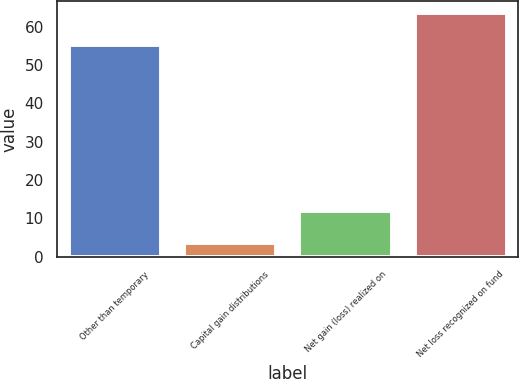Convert chart to OTSL. <chart><loc_0><loc_0><loc_500><loc_500><bar_chart><fcel>Other than temporary<fcel>Capital gain distributions<fcel>Net gain (loss) realized on<fcel>Net loss recognized on fund<nl><fcel>55.2<fcel>3.6<fcel>11.9<fcel>63.5<nl></chart> 